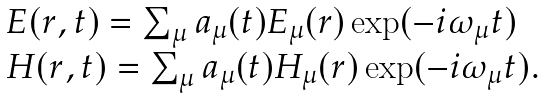<formula> <loc_0><loc_0><loc_500><loc_500>\begin{array} { l } { E } ( { r } , t ) = \sum _ { \mu } a _ { \mu } ( t ) { E } _ { \mu } ( { r } ) \exp ( - i \omega _ { \mu } t ) \\ { H } ( { r } , t ) = \sum _ { \mu } a _ { \mu } ( t ) { H } _ { \mu } ( { r ) } \exp ( - i \omega _ { \mu } t ) . \end{array}</formula> 